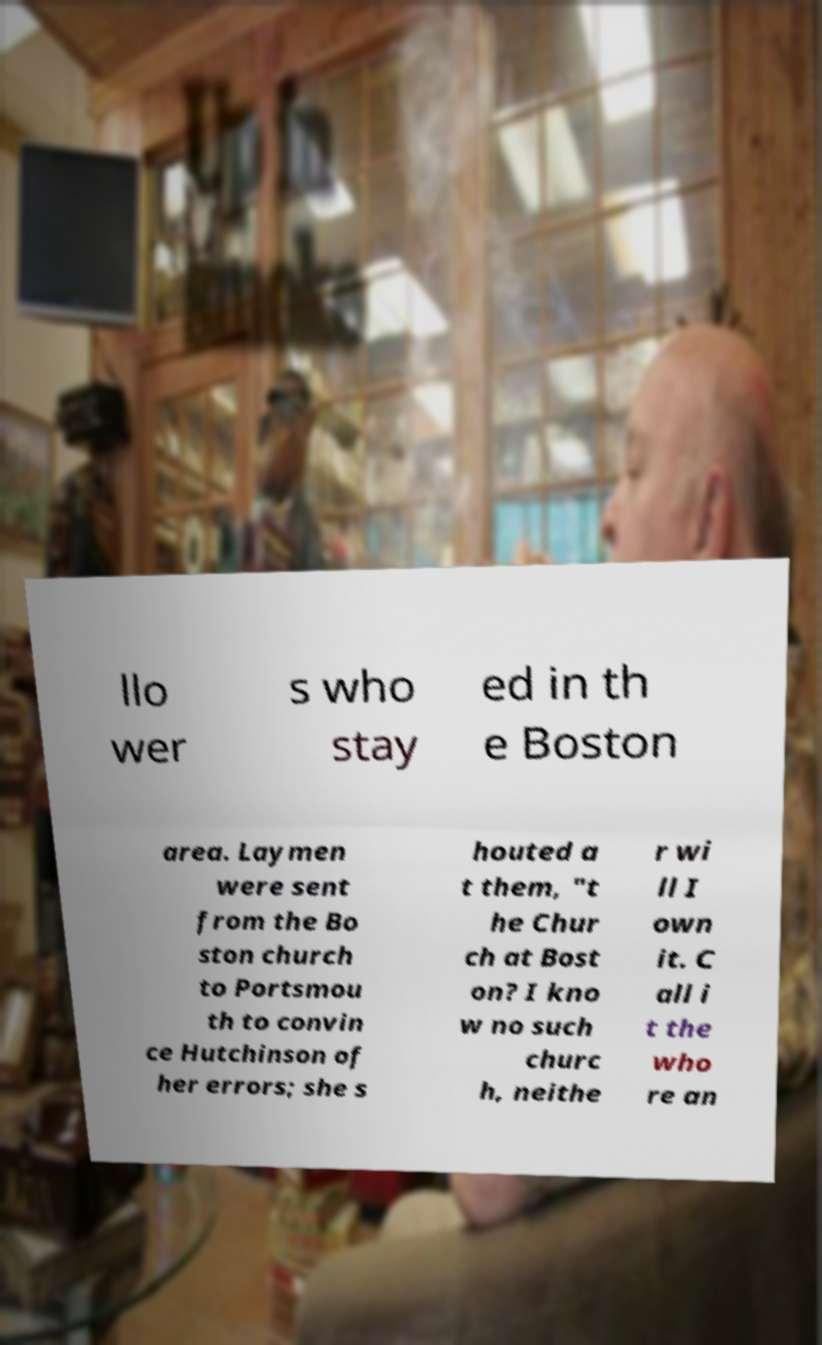What messages or text are displayed in this image? I need them in a readable, typed format. llo wer s who stay ed in th e Boston area. Laymen were sent from the Bo ston church to Portsmou th to convin ce Hutchinson of her errors; she s houted a t them, "t he Chur ch at Bost on? I kno w no such churc h, neithe r wi ll I own it. C all i t the who re an 